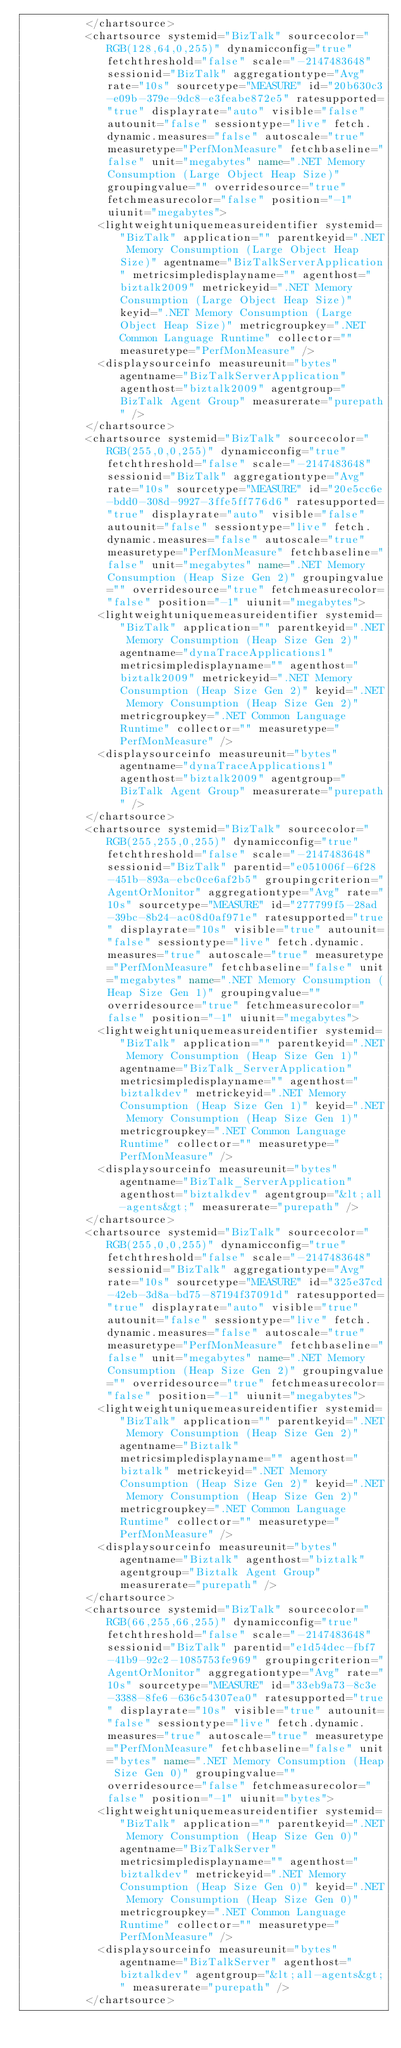<code> <loc_0><loc_0><loc_500><loc_500><_XML_>          </chartsource>
          <chartsource systemid="BizTalk" sourcecolor="RGB(128,64,0,255)" dynamicconfig="true" fetchthreshold="false" scale="-2147483648" sessionid="BizTalk" aggregationtype="Avg" rate="10s" sourcetype="MEASURE" id="20b630c3-e09b-379e-9dc8-e3feabe872e5" ratesupported="true" displayrate="auto" visible="false" autounit="false" sessiontype="live" fetch.dynamic.measures="false" autoscale="true" measuretype="PerfMonMeasure" fetchbaseline="false" unit="megabytes" name=".NET Memory Consumption (Large Object Heap Size)" groupingvalue="" overridesource="true" fetchmeasurecolor="false" position="-1" uiunit="megabytes">
            <lightweightuniquemeasureidentifier systemid="BizTalk" application="" parentkeyid=".NET Memory Consumption (Large Object Heap Size)" agentname="BizTalkServerApplication" metricsimpledisplayname="" agenthost="biztalk2009" metrickeyid=".NET Memory Consumption (Large Object Heap Size)" keyid=".NET Memory Consumption (Large Object Heap Size)" metricgroupkey=".NET Common Language Runtime" collector="" measuretype="PerfMonMeasure" />
            <displaysourceinfo measureunit="bytes" agentname="BizTalkServerApplication" agenthost="biztalk2009" agentgroup="BizTalk Agent Group" measurerate="purepath" />
          </chartsource>
          <chartsource systemid="BizTalk" sourcecolor="RGB(255,0,0,255)" dynamicconfig="true" fetchthreshold="false" scale="-2147483648" sessionid="BizTalk" aggregationtype="Avg" rate="10s" sourcetype="MEASURE" id="20e5cc6e-bdd0-308d-9927-3ffe5ff776d6" ratesupported="true" displayrate="auto" visible="false" autounit="false" sessiontype="live" fetch.dynamic.measures="false" autoscale="true" measuretype="PerfMonMeasure" fetchbaseline="false" unit="megabytes" name=".NET Memory Consumption (Heap Size Gen 2)" groupingvalue="" overridesource="true" fetchmeasurecolor="false" position="-1" uiunit="megabytes">
            <lightweightuniquemeasureidentifier systemid="BizTalk" application="" parentkeyid=".NET Memory Consumption (Heap Size Gen 2)" agentname="dynaTraceApplications1" metricsimpledisplayname="" agenthost="biztalk2009" metrickeyid=".NET Memory Consumption (Heap Size Gen 2)" keyid=".NET Memory Consumption (Heap Size Gen 2)" metricgroupkey=".NET Common Language Runtime" collector="" measuretype="PerfMonMeasure" />
            <displaysourceinfo measureunit="bytes" agentname="dynaTraceApplications1" agenthost="biztalk2009" agentgroup="BizTalk Agent Group" measurerate="purepath" />
          </chartsource>
          <chartsource systemid="BizTalk" sourcecolor="RGB(255,255,0,255)" dynamicconfig="true" fetchthreshold="false" scale="-2147483648" sessionid="BizTalk" parentid="e051006f-6f28-451b-893a-ebc0ce6af2b5" groupingcriterion="AgentOrMonitor" aggregationtype="Avg" rate="10s" sourcetype="MEASURE" id="277799f5-28ad-39bc-8b24-ac08d0af971e" ratesupported="true" displayrate="10s" visible="true" autounit="false" sessiontype="live" fetch.dynamic.measures="true" autoscale="true" measuretype="PerfMonMeasure" fetchbaseline="false" unit="megabytes" name=".NET Memory Consumption (Heap Size Gen 1)" groupingvalue="" overridesource="true" fetchmeasurecolor="false" position="-1" uiunit="megabytes">
            <lightweightuniquemeasureidentifier systemid="BizTalk" application="" parentkeyid=".NET Memory Consumption (Heap Size Gen 1)" agentname="BizTalk_ServerApplication" metricsimpledisplayname="" agenthost="biztalkdev" metrickeyid=".NET Memory Consumption (Heap Size Gen 1)" keyid=".NET Memory Consumption (Heap Size Gen 1)" metricgroupkey=".NET Common Language Runtime" collector="" measuretype="PerfMonMeasure" />
            <displaysourceinfo measureunit="bytes" agentname="BizTalk_ServerApplication" agenthost="biztalkdev" agentgroup="&lt;all-agents&gt;" measurerate="purepath" />
          </chartsource>
          <chartsource systemid="BizTalk" sourcecolor="RGB(255,0,0,255)" dynamicconfig="true" fetchthreshold="false" scale="-2147483648" sessionid="BizTalk" aggregationtype="Avg" rate="10s" sourcetype="MEASURE" id="325e37cd-42eb-3d8a-bd75-87194f37091d" ratesupported="true" displayrate="auto" visible="true" autounit="false" sessiontype="live" fetch.dynamic.measures="false" autoscale="true" measuretype="PerfMonMeasure" fetchbaseline="false" unit="megabytes" name=".NET Memory Consumption (Heap Size Gen 2)" groupingvalue="" overridesource="true" fetchmeasurecolor="false" position="-1" uiunit="megabytes">
            <lightweightuniquemeasureidentifier systemid="BizTalk" application="" parentkeyid=".NET Memory Consumption (Heap Size Gen 2)" agentname="Biztalk" metricsimpledisplayname="" agenthost="biztalk" metrickeyid=".NET Memory Consumption (Heap Size Gen 2)" keyid=".NET Memory Consumption (Heap Size Gen 2)" metricgroupkey=".NET Common Language Runtime" collector="" measuretype="PerfMonMeasure" />
            <displaysourceinfo measureunit="bytes" agentname="Biztalk" agenthost="biztalk" agentgroup="Biztalk Agent Group" measurerate="purepath" />
          </chartsource>
          <chartsource systemid="BizTalk" sourcecolor="RGB(66,255,66,255)" dynamicconfig="true" fetchthreshold="false" scale="-2147483648" sessionid="BizTalk" parentid="e1d54dec-fbf7-41b9-92c2-1085753fe969" groupingcriterion="AgentOrMonitor" aggregationtype="Avg" rate="10s" sourcetype="MEASURE" id="33eb9a73-8c3e-3388-8fe6-636c54307ea0" ratesupported="true" displayrate="10s" visible="true" autounit="false" sessiontype="live" fetch.dynamic.measures="true" autoscale="true" measuretype="PerfMonMeasure" fetchbaseline="false" unit="bytes" name=".NET Memory Consumption (Heap Size Gen 0)" groupingvalue="" overridesource="false" fetchmeasurecolor="false" position="-1" uiunit="bytes">
            <lightweightuniquemeasureidentifier systemid="BizTalk" application="" parentkeyid=".NET Memory Consumption (Heap Size Gen 0)" agentname="BizTalkServer" metricsimpledisplayname="" agenthost="biztalkdev" metrickeyid=".NET Memory Consumption (Heap Size Gen 0)" keyid=".NET Memory Consumption (Heap Size Gen 0)" metricgroupkey=".NET Common Language Runtime" collector="" measuretype="PerfMonMeasure" />
            <displaysourceinfo measureunit="bytes" agentname="BizTalkServer" agenthost="biztalkdev" agentgroup="&lt;all-agents&gt;" measurerate="purepath" />
          </chartsource></code> 